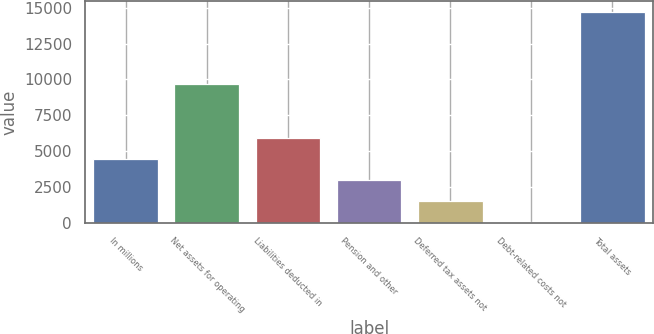Convert chart. <chart><loc_0><loc_0><loc_500><loc_500><bar_chart><fcel>In millions<fcel>Net assets for operating<fcel>Liabilities deducted in<fcel>Pension and other<fcel>Deferred tax assets not<fcel>Debt-related costs not<fcel>Total assets<nl><fcel>4441.5<fcel>9646<fcel>5911<fcel>2972<fcel>1502.5<fcel>33<fcel>14728<nl></chart> 